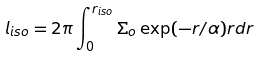<formula> <loc_0><loc_0><loc_500><loc_500>l _ { i s o } = 2 \pi \int ^ { r _ { i s o } } _ { 0 } \Sigma _ { o } \exp ( - r / \alpha ) r d r</formula> 